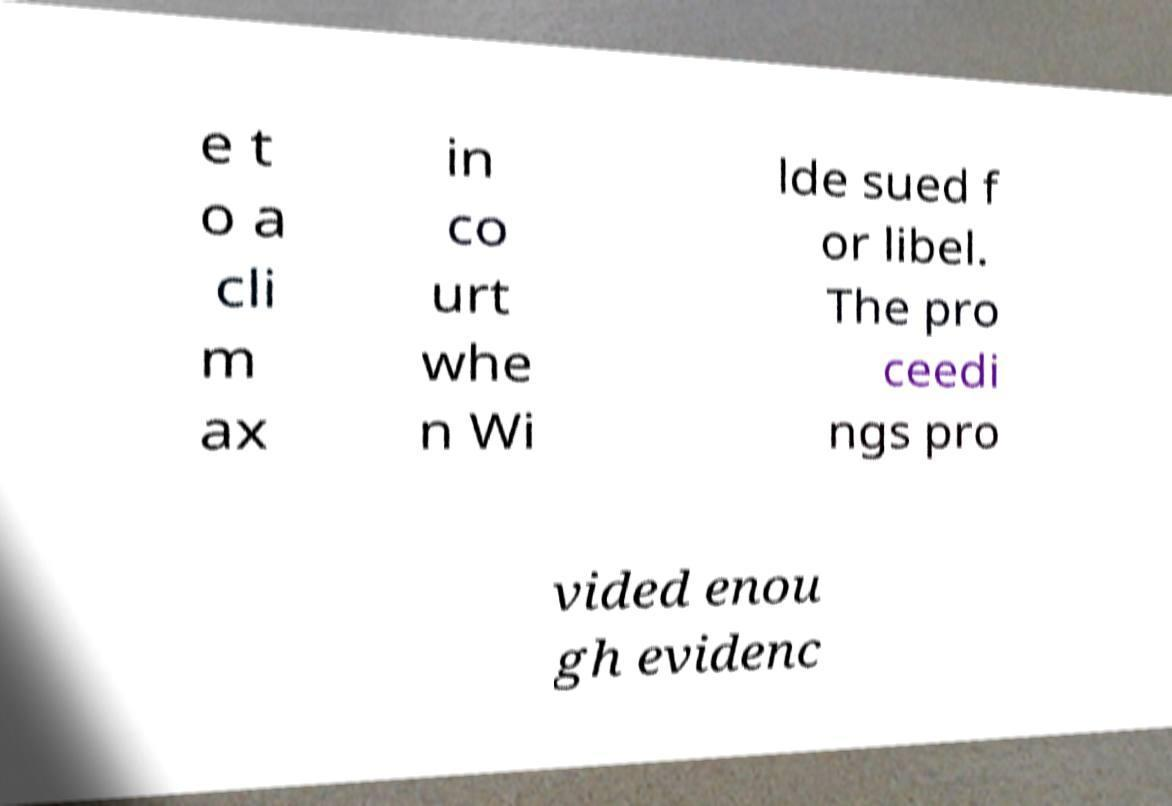Could you assist in decoding the text presented in this image and type it out clearly? e t o a cli m ax in co urt whe n Wi lde sued f or libel. The pro ceedi ngs pro vided enou gh evidenc 